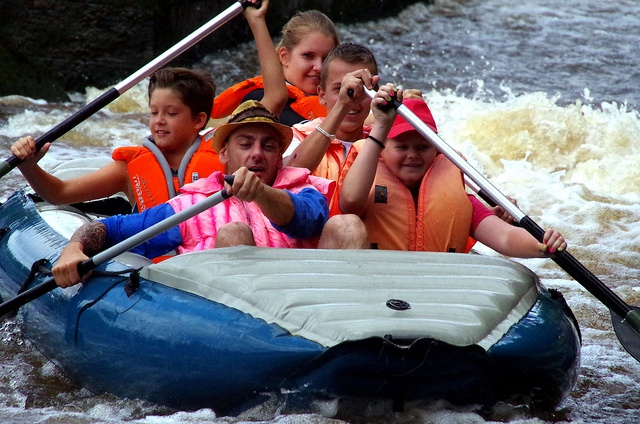Describe the objects in this image and their specific colors. I can see boat in black, lightblue, navy, and darkgray tones, people in black, maroon, brown, and violet tones, people in black, maroon, and brown tones, people in black, maroon, red, and brown tones, and people in black, brown, maroon, and lightpink tones in this image. 